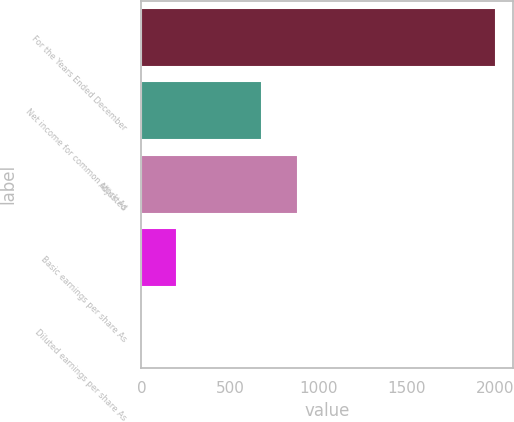Convert chart to OTSL. <chart><loc_0><loc_0><loc_500><loc_500><bar_chart><fcel>For the Years Ended December<fcel>Net income for common stock As<fcel>Adjusted<fcel>Basic earnings per share As<fcel>Diluted earnings per share As<nl><fcel>2001<fcel>682.2<fcel>881.98<fcel>202.99<fcel>3.21<nl></chart> 